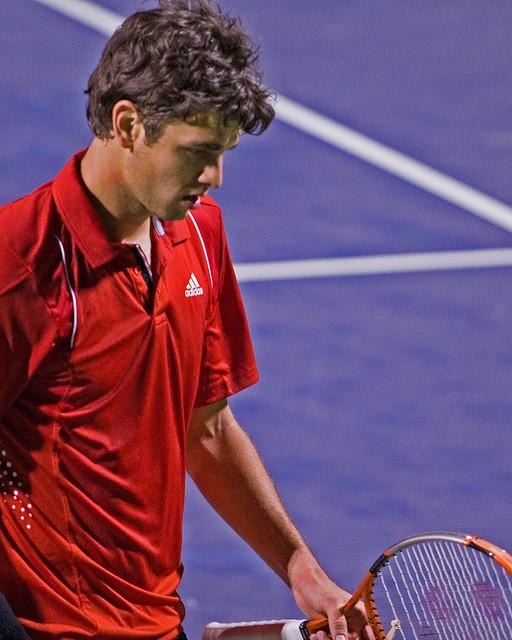What brand shirt is the tennis player wearing?
Concise answer only. Adidas. Are tight-fitting clothes the best option for players of this sport?
Keep it brief. No. Is the man blonde?
Quick response, please. No. 